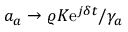<formula> <loc_0><loc_0><loc_500><loc_500>a _ { a } \rightarrow \varrho K e ^ { j \delta t } / \gamma _ { a }</formula> 